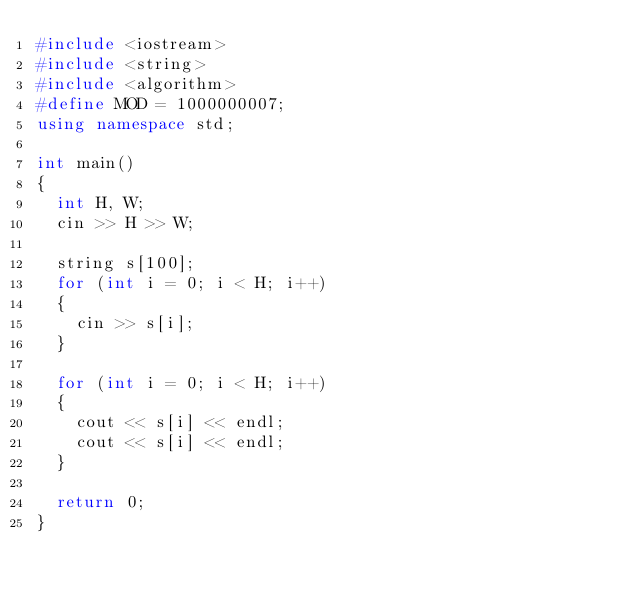Convert code to text. <code><loc_0><loc_0><loc_500><loc_500><_C++_>#include <iostream>
#include <string>
#include <algorithm>
#define	MOD = 1000000007;
using namespace std;

int main()
{
	int H, W;
	cin >> H >> W;

	string s[100];
	for (int i = 0; i < H; i++)
	{
		cin >> s[i];
	}

	for (int i = 0; i < H; i++)
	{
		cout << s[i] << endl;
		cout << s[i] << endl;
	}

	return 0;
}</code> 